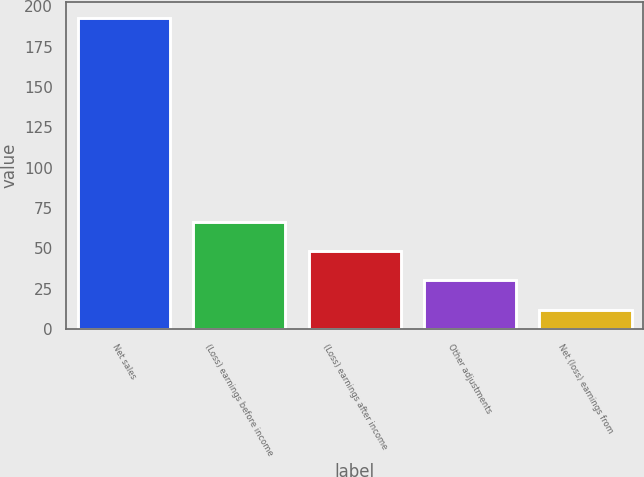Convert chart. <chart><loc_0><loc_0><loc_500><loc_500><bar_chart><fcel>Net sales<fcel>(Loss) earnings before income<fcel>(Loss) earnings after income<fcel>Other adjustments<fcel>Net (loss) earnings from<nl><fcel>193<fcel>66.3<fcel>48.2<fcel>30.1<fcel>12<nl></chart> 